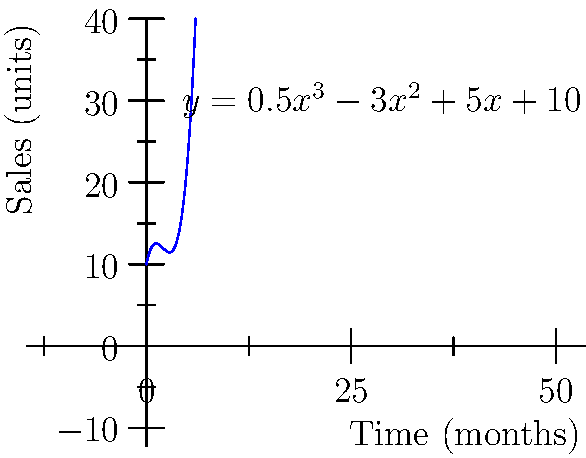As a specialty tea distributor, you've been tracking the sales of a unique blend in a coffee shop's reading area. The sales growth over time can be modeled by the polynomial function $y = 0.5x^3 - 3x^2 + 5x + 10$, where $y$ represents the number of tea units sold and $x$ represents the time in months. What will be the total increase in tea sales from the 2nd month to the 5th month? To find the total increase in tea sales from the 2nd month to the 5th month, we need to:

1. Calculate the sales at the 2nd month:
   $y(2) = 0.5(2)^3 - 3(2)^2 + 5(2) + 10$
   $= 0.5(8) - 3(4) + 10 + 10$
   $= 4 - 12 + 10 + 10 = 12$ units

2. Calculate the sales at the 5th month:
   $y(5) = 0.5(5)^3 - 3(5)^2 + 5(5) + 10$
   $= 0.5(125) - 3(25) + 25 + 10$
   $= 62.5 - 75 + 25 + 10 = 22.5$ units

3. Calculate the difference:
   Increase = $y(5) - y(2) = 22.5 - 12 = 10.5$ units

Therefore, the total increase in tea sales from the 2nd month to the 5th month is 10.5 units.
Answer: 10.5 units 